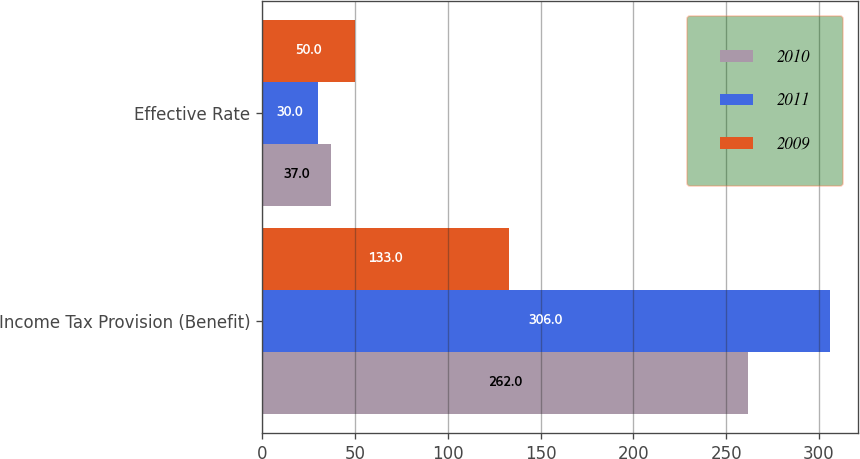<chart> <loc_0><loc_0><loc_500><loc_500><stacked_bar_chart><ecel><fcel>Income Tax Provision (Benefit)<fcel>Effective Rate<nl><fcel>2010<fcel>262<fcel>37<nl><fcel>2011<fcel>306<fcel>30<nl><fcel>2009<fcel>133<fcel>50<nl></chart> 